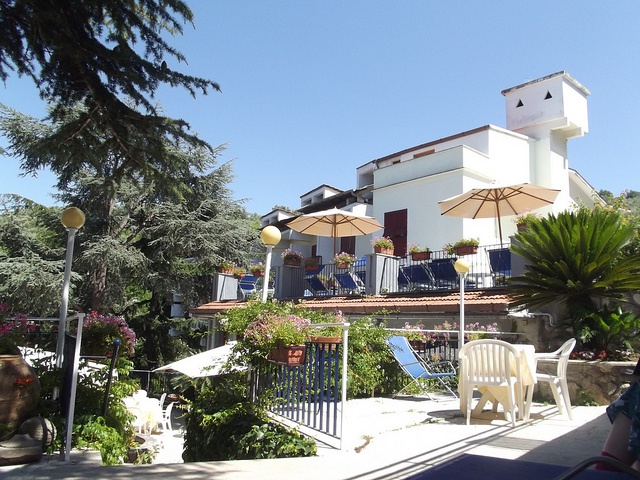Describe the objects in this image and their specific colors. I can see umbrella in black, tan, white, and maroon tones, chair in black, ivory, tan, and darkgray tones, potted plant in black, olive, and maroon tones, people in black and gray tones, and chair in black, white, lightgray, darkgray, and gray tones in this image. 